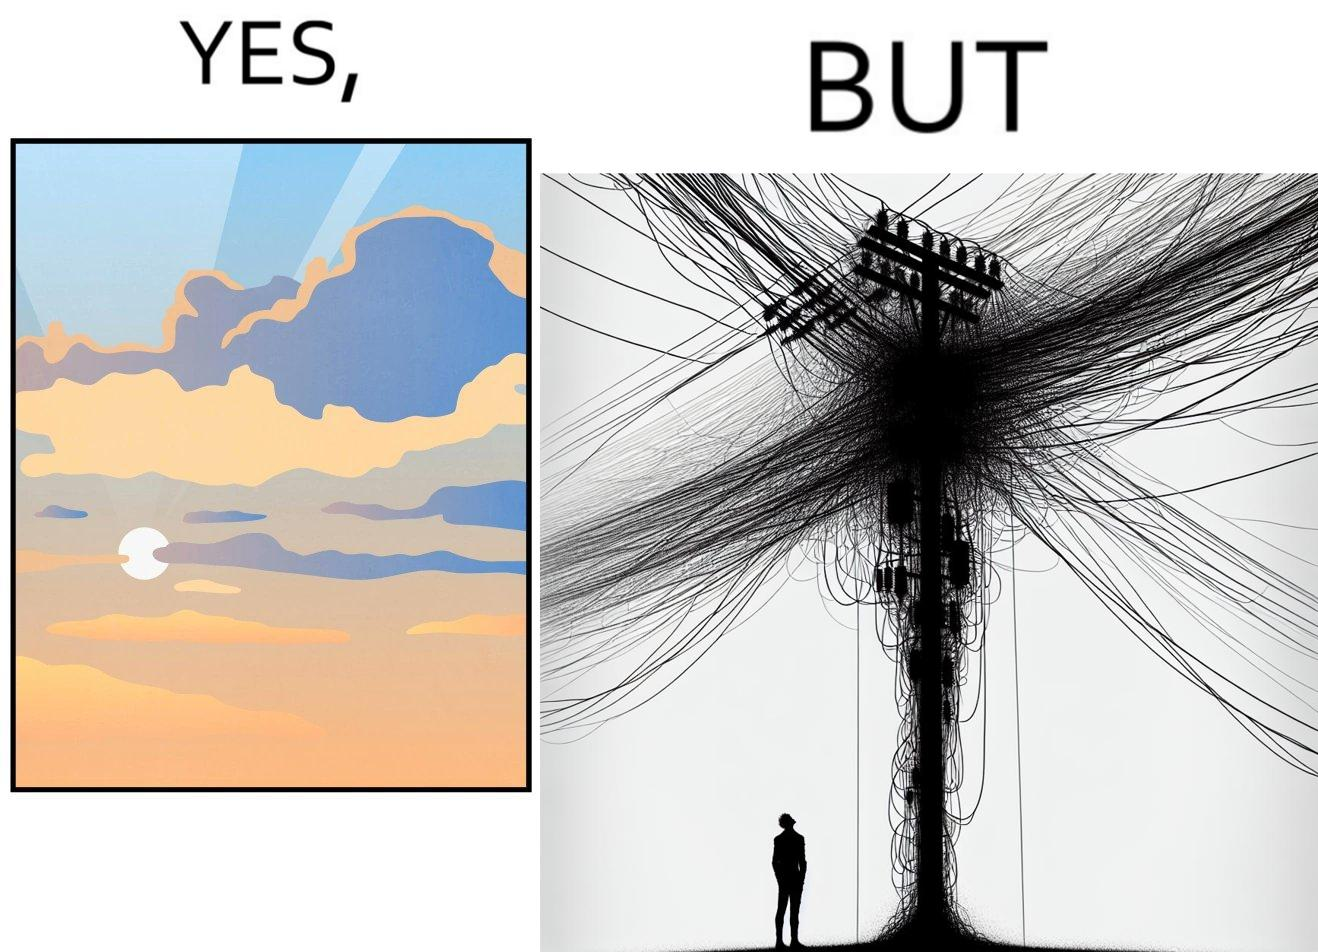What is shown in the left half versus the right half of this image? In the left part of the image: a clear sky with sun and clouds In the right part of the image: an electricity pole with a lot of wires over it 